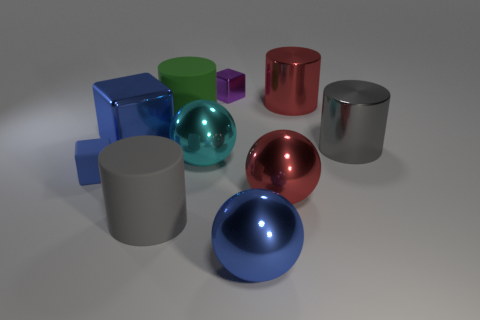Is there a big metal sphere of the same color as the small rubber cube?
Make the answer very short. Yes. What material is the small block that is the same color as the big block?
Make the answer very short. Rubber. Does the ball that is on the right side of the blue sphere have the same material as the green cylinder?
Give a very brief answer. No. What is the size of the other cube that is the same color as the big block?
Ensure brevity in your answer.  Small. There is a metallic cylinder behind the big gray metallic cylinder; does it have the same color as the ball to the right of the blue metal sphere?
Make the answer very short. Yes. What number of other things are there of the same shape as the cyan metal object?
Provide a short and direct response. 2. What shape is the tiny blue object that is the same material as the green cylinder?
Ensure brevity in your answer.  Cube. Is there any other thing that is the same color as the big cube?
Offer a terse response. Yes. Is the number of big blue metal objects that are in front of the small purple metallic block greater than the number of small purple metallic cylinders?
Offer a very short reply. Yes. What material is the small blue object?
Offer a very short reply. Rubber. 